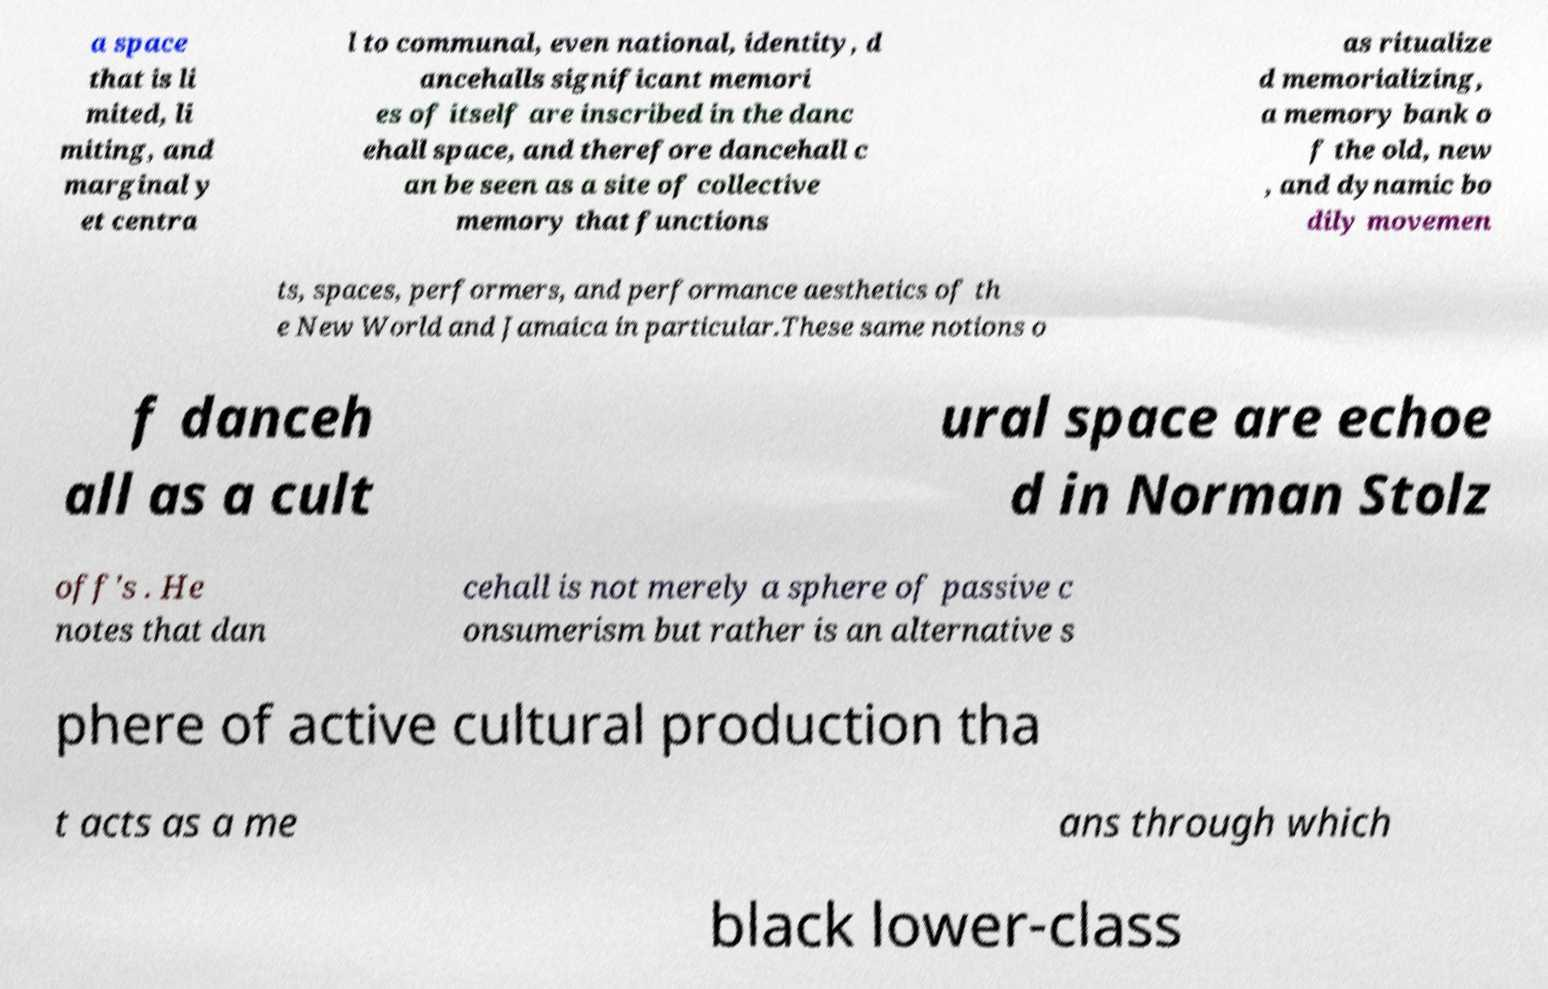There's text embedded in this image that I need extracted. Can you transcribe it verbatim? a space that is li mited, li miting, and marginal y et centra l to communal, even national, identity, d ancehalls significant memori es of itself are inscribed in the danc ehall space, and therefore dancehall c an be seen as a site of collective memory that functions as ritualize d memorializing, a memory bank o f the old, new , and dynamic bo dily movemen ts, spaces, performers, and performance aesthetics of th e New World and Jamaica in particular.These same notions o f danceh all as a cult ural space are echoe d in Norman Stolz off's . He notes that dan cehall is not merely a sphere of passive c onsumerism but rather is an alternative s phere of active cultural production tha t acts as a me ans through which black lower-class 